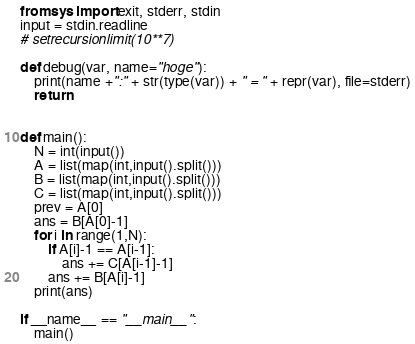<code> <loc_0><loc_0><loc_500><loc_500><_Python_>from sys import exit, stderr, stdin
input = stdin.readline
# setrecursionlimit(10**7)

def debug(var, name="hoge"):
    print(name +":" + str(type(var)) + " = " + repr(var), file=stderr)
    return


def main():
    N = int(input())
    A = list(map(int,input().split()))
    B = list(map(int,input().split()))
    C = list(map(int,input().split()))
    prev = A[0]
    ans = B[A[0]-1]
    for i in range(1,N):
        if A[i]-1 == A[i-1]:
            ans += C[A[i-1]-1]
        ans += B[A[i]-1]
    print(ans)

if __name__ == "__main__":
    main()
</code> 